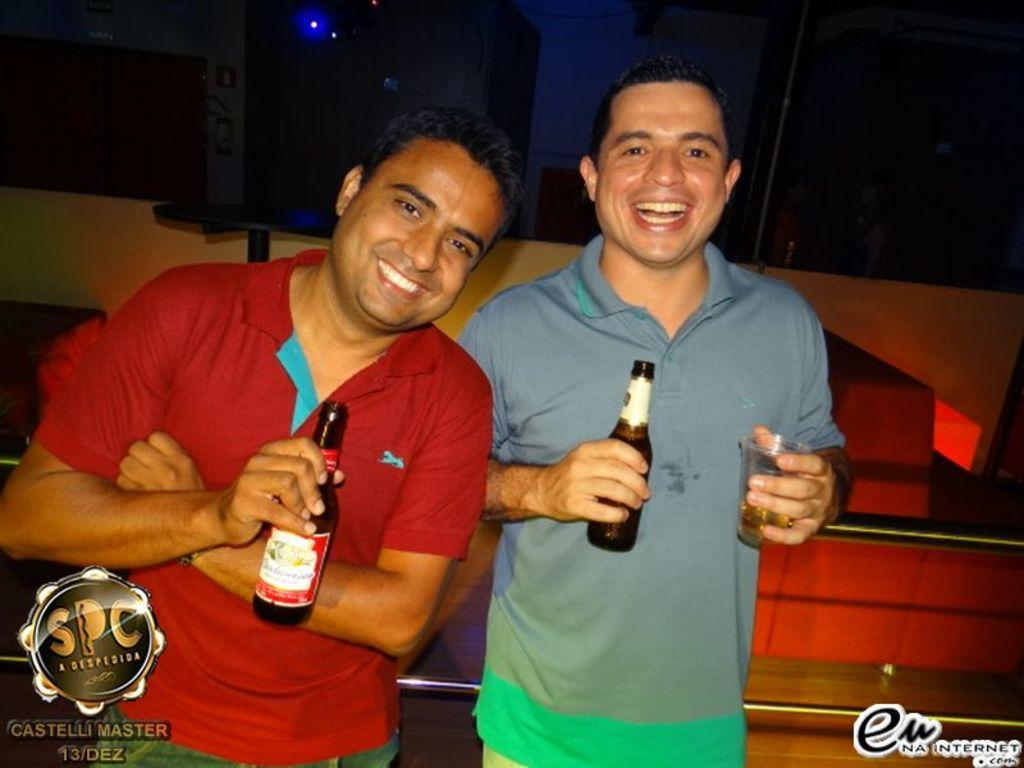How many people are in the image? There are two persons in the image. What colors are the shirts of the two persons? One person is wearing a red shirt, and the other person is wearing a blue shirt. What are the two persons doing in the image? Both persons are standing. What are the two persons holding in their hands? Both persons are holding beer bottles in their hands. What type of chair is the person in the red shirt sitting on in the image? There is no chair present in the image; both persons are standing. How does the person in the blue shirt feel about the situation in the image? The image does not provide any information about the feelings of the person in the blue shirt or any other person. 